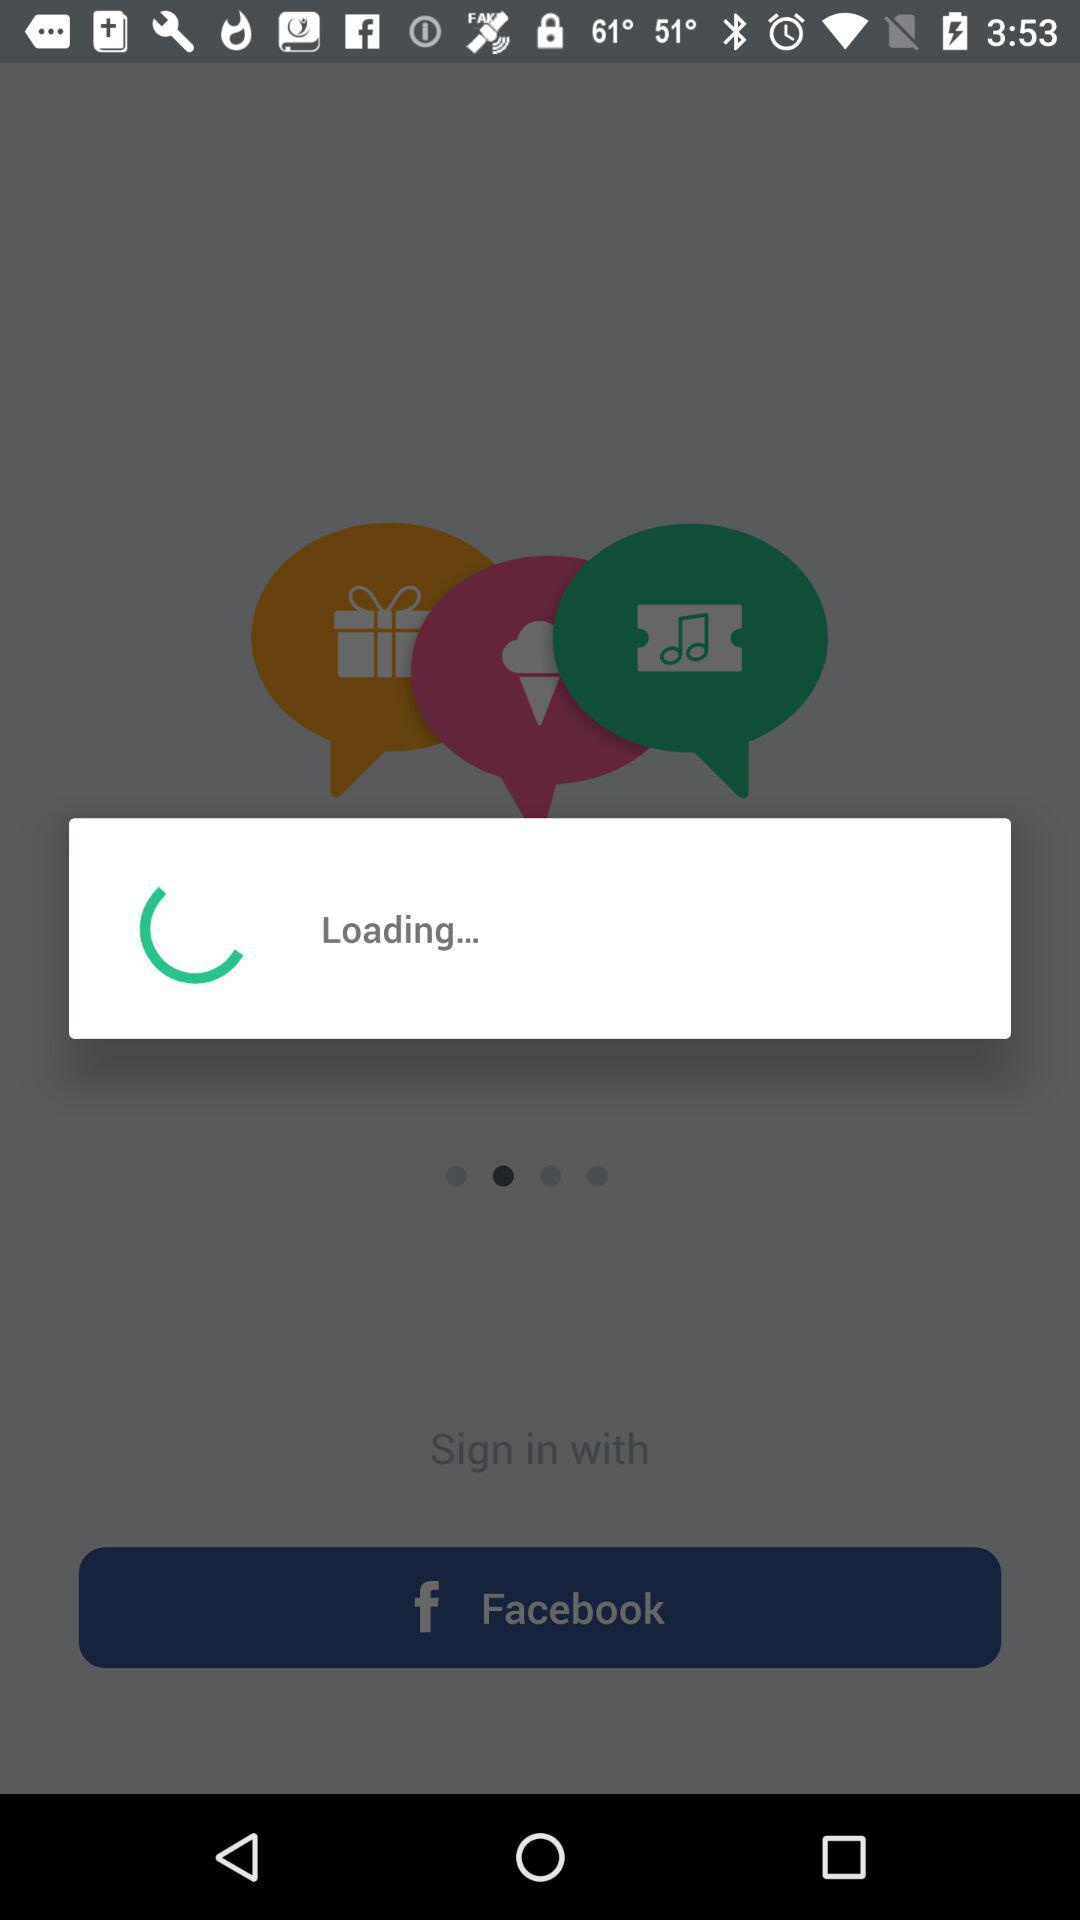What is the user name to continue the profile? The user name to continue the profile is Sam. 